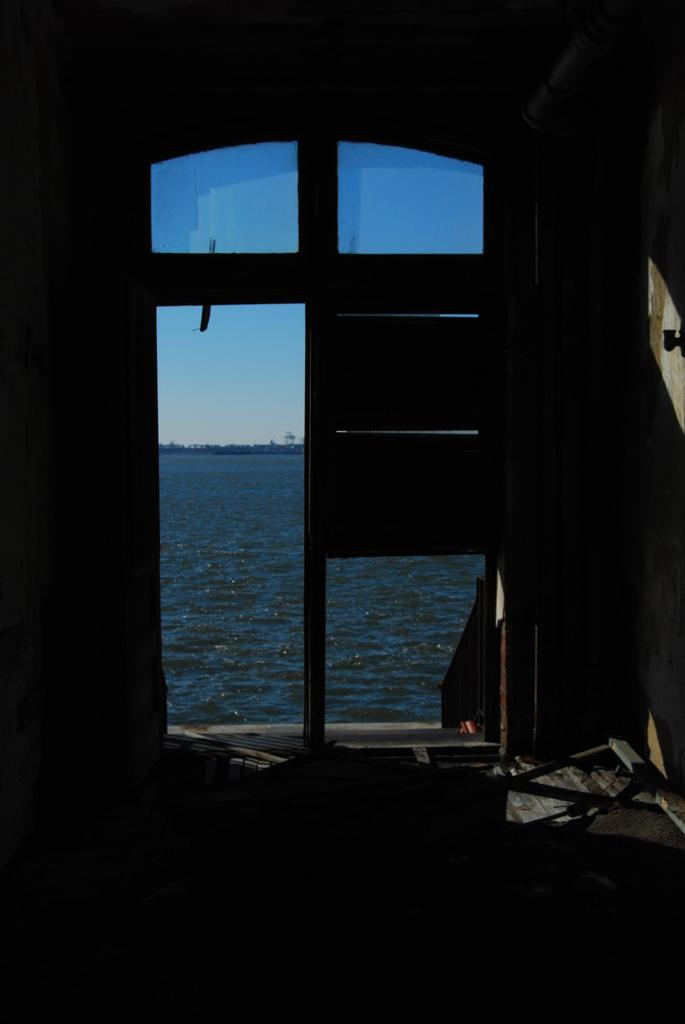What type of door can be seen in the image? There is a glass door in the image. What can be seen beneath the door in the image? The ground is visible in the image. What is located behind the door in the image? There is a wall in the image. What natural element is visible in the image? Water is visible in the image. What is visible above the water in the image? The sky is visible in the image. What type of marble is being used to decorate the door in the image? There is no marble present in the image; it features a glass door. Can you see a hen in the image? There is no hen present in the image. 